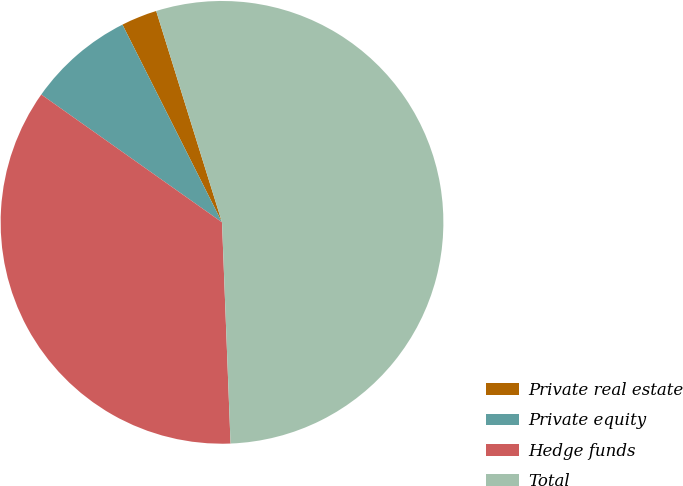Convert chart to OTSL. <chart><loc_0><loc_0><loc_500><loc_500><pie_chart><fcel>Private real estate<fcel>Private equity<fcel>Hedge funds<fcel>Total<nl><fcel>2.62%<fcel>7.78%<fcel>35.41%<fcel>54.19%<nl></chart> 